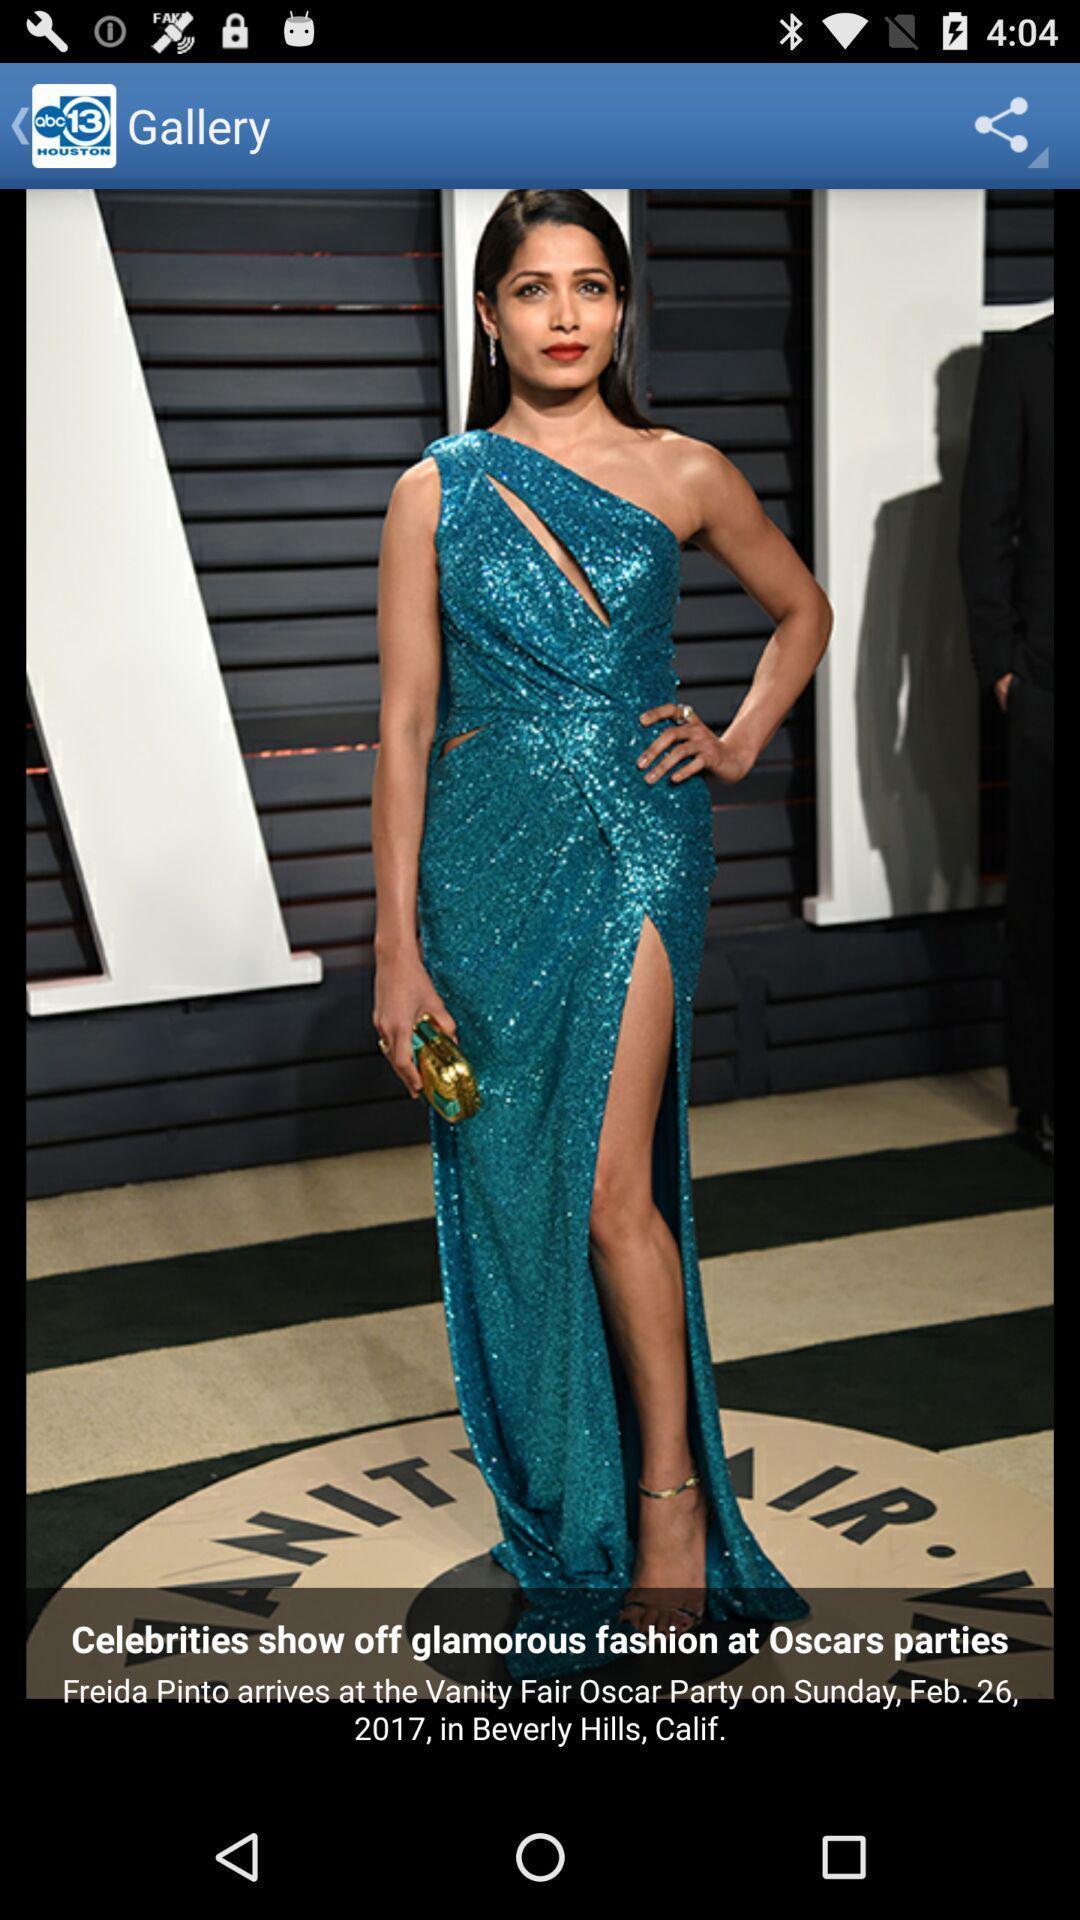Provide a description of this screenshot. Screen displaying the image with description. 